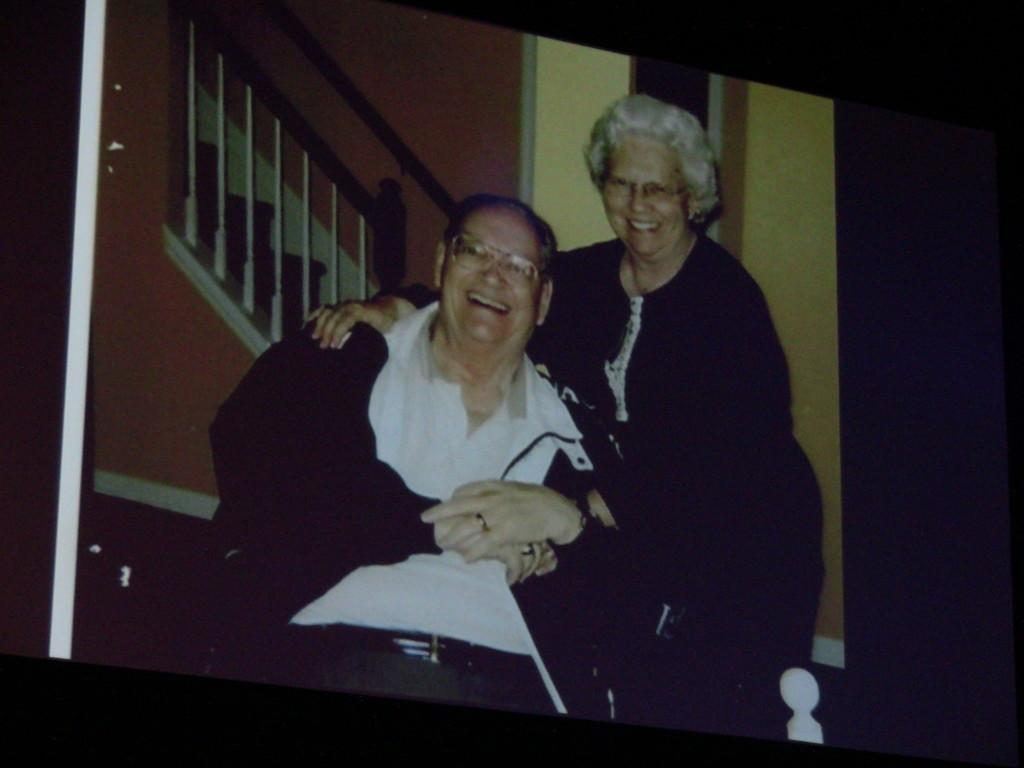Who is present in the image? There is a man and a woman in the image. What are the facial expressions of the people in the image? Both the man and the woman are smiling. What architectural features can be seen in the background of the image? There are steps and a wall visible in the background of the image. How many goldfish can be seen swimming in the background of the image? There are no goldfish present in the image. What type of weather is depicted in the image, given the visibility of the wall and steps? The visibility of the wall and steps does not provide information about the weather in the image. 